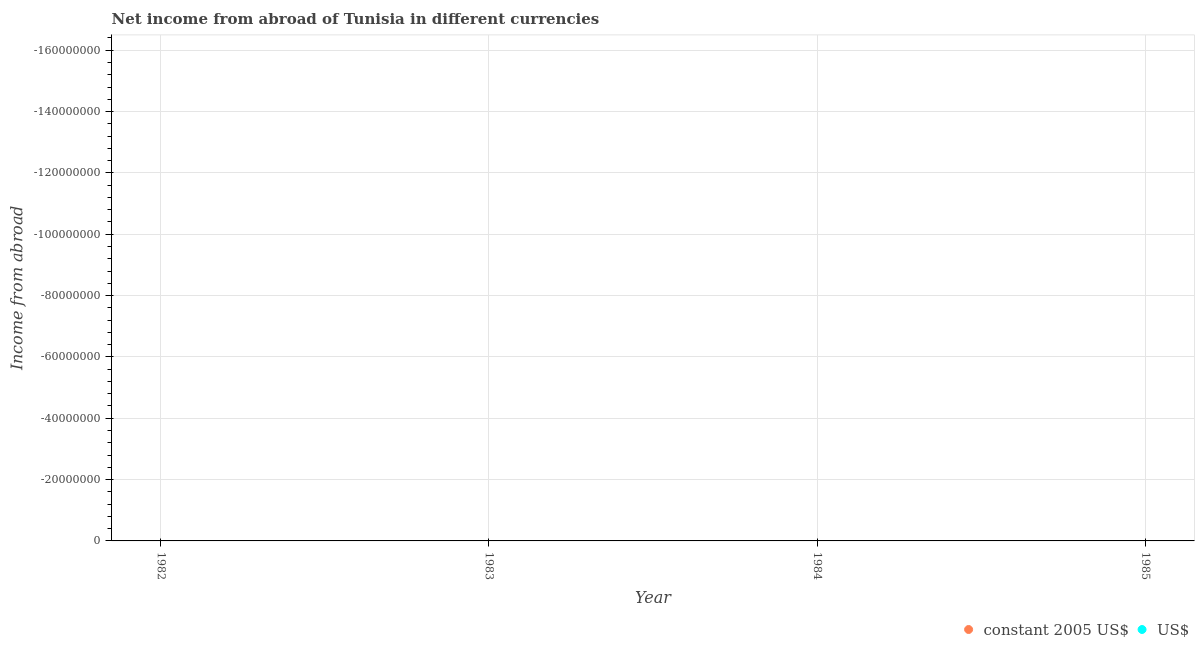How many different coloured dotlines are there?
Your answer should be compact. 0. Is the number of dotlines equal to the number of legend labels?
Give a very brief answer. No. What is the income from abroad in us$ in 1983?
Offer a terse response. 0. What is the average income from abroad in us$ per year?
Make the answer very short. 0. In how many years, is the income from abroad in constant 2005 us$ greater than -116000000 units?
Ensure brevity in your answer.  0. How many dotlines are there?
Make the answer very short. 0. How many years are there in the graph?
Keep it short and to the point. 4. Does the graph contain any zero values?
Make the answer very short. Yes. Does the graph contain grids?
Offer a very short reply. Yes. What is the title of the graph?
Provide a succinct answer. Net income from abroad of Tunisia in different currencies. Does "Sanitation services" appear as one of the legend labels in the graph?
Provide a succinct answer. No. What is the label or title of the X-axis?
Provide a succinct answer. Year. What is the label or title of the Y-axis?
Offer a very short reply. Income from abroad. What is the Income from abroad of constant 2005 US$ in 1982?
Your answer should be very brief. 0. What is the Income from abroad of constant 2005 US$ in 1983?
Make the answer very short. 0. What is the Income from abroad in constant 2005 US$ in 1985?
Make the answer very short. 0. What is the Income from abroad in US$ in 1985?
Your answer should be very brief. 0. What is the average Income from abroad in constant 2005 US$ per year?
Your response must be concise. 0. 